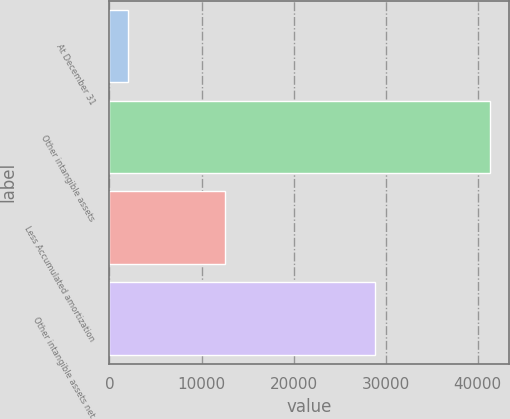Convert chart. <chart><loc_0><loc_0><loc_500><loc_500><bar_chart><fcel>At December 31<fcel>Other intangible assets<fcel>Less Accumulated amortization<fcel>Other intangible assets net<nl><fcel>2014<fcel>41327<fcel>12512<fcel>28815<nl></chart> 